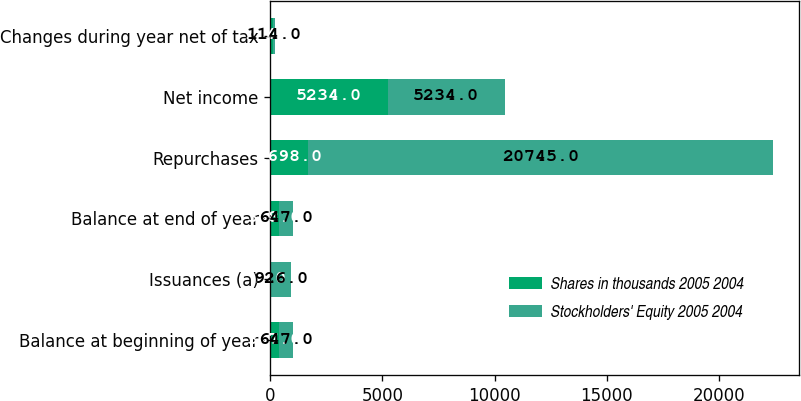<chart> <loc_0><loc_0><loc_500><loc_500><stacked_bar_chart><ecel><fcel>Balance at beginning of year<fcel>Issuances (a)<fcel>Balance at end of year<fcel>Repurchases<fcel>Net income<fcel>Changes during year net of tax<nl><fcel>Shares in thousands 2005 2004<fcel>367<fcel>1<fcel>368<fcel>1698<fcel>5234<fcel>114<nl><fcel>Stockholders' Equity 2005 2004<fcel>647<fcel>926<fcel>647<fcel>20745<fcel>5234<fcel>114<nl></chart> 